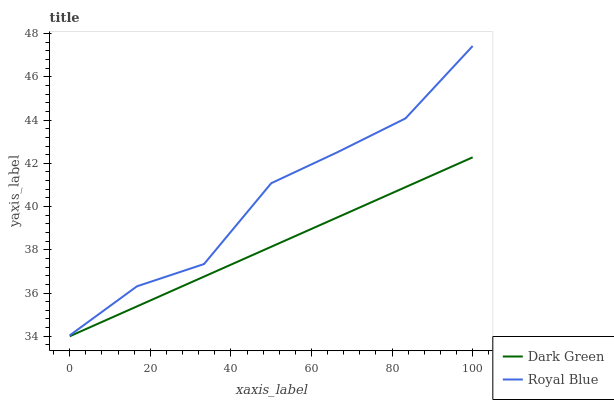Does Dark Green have the minimum area under the curve?
Answer yes or no. Yes. Does Royal Blue have the maximum area under the curve?
Answer yes or no. Yes. Does Dark Green have the maximum area under the curve?
Answer yes or no. No. Is Dark Green the smoothest?
Answer yes or no. Yes. Is Royal Blue the roughest?
Answer yes or no. Yes. Is Dark Green the roughest?
Answer yes or no. No. Does Dark Green have the lowest value?
Answer yes or no. Yes. Does Royal Blue have the highest value?
Answer yes or no. Yes. Does Dark Green have the highest value?
Answer yes or no. No. Is Dark Green less than Royal Blue?
Answer yes or no. Yes. Is Royal Blue greater than Dark Green?
Answer yes or no. Yes. Does Dark Green intersect Royal Blue?
Answer yes or no. No. 